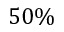Convert formula to latex. <formula><loc_0><loc_0><loc_500><loc_500>5 0 \%</formula> 